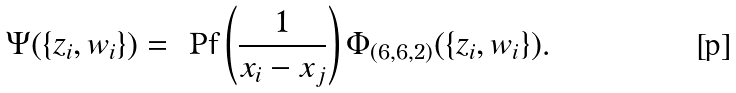<formula> <loc_0><loc_0><loc_500><loc_500>\Psi ( \{ z _ { i } , w _ { i } \} ) = \text { Pf} \left ( \frac { 1 } { x _ { i } - x _ { j } } \right ) \Phi _ { ( 6 , 6 , 2 ) } ( \{ z _ { i } , w _ { i } \} ) .</formula> 